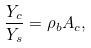<formula> <loc_0><loc_0><loc_500><loc_500>\frac { Y _ { c } } { Y _ { s } } = \rho _ { b } A _ { c } ,</formula> 